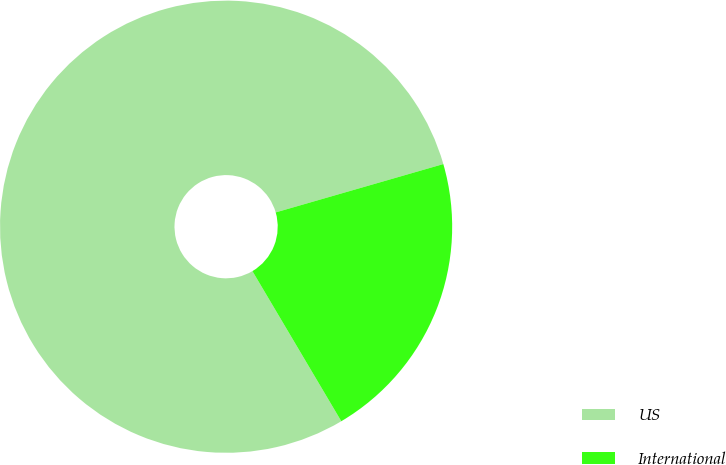Convert chart to OTSL. <chart><loc_0><loc_0><loc_500><loc_500><pie_chart><fcel>US<fcel>International<nl><fcel>79.04%<fcel>20.96%<nl></chart> 